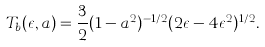<formula> <loc_0><loc_0><loc_500><loc_500>T _ { b } ( \epsilon , a ) = \frac { 3 } { 2 } ( 1 - a ^ { 2 } ) ^ { - 1 / 2 } ( 2 \epsilon - 4 \epsilon ^ { 2 } ) ^ { 1 / 2 } .</formula> 